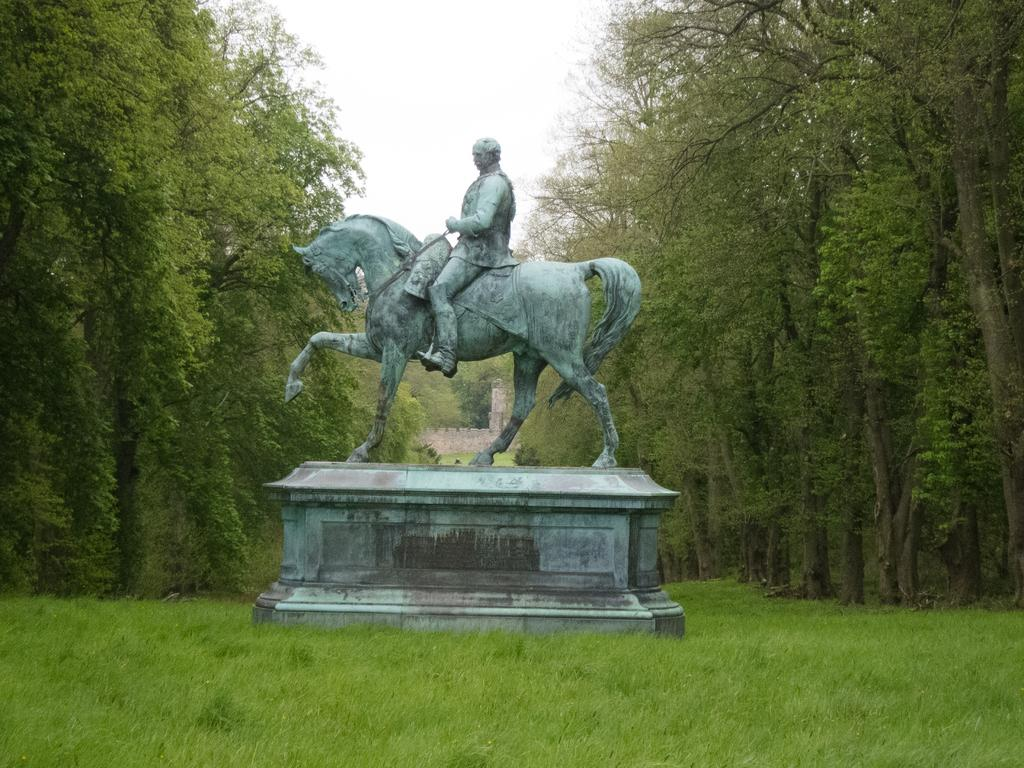What is the main subject in the center of the image? There is a statue in the center of the image. What type of vegetation can be seen in the image? There is grass visible in the image, and there is a group of trees as well. What type of structure is present in the image? There is a wall in the image. What is visible in the sky in the image? The sky is visible in the image and appears cloudy. What type of meal is being prepared in the bucket in the image? There is no bucket or meal preparation present in the image. What type of blade is being used to cut the grass in the image? There is no blade or grass cutting activity depicted in the image. 